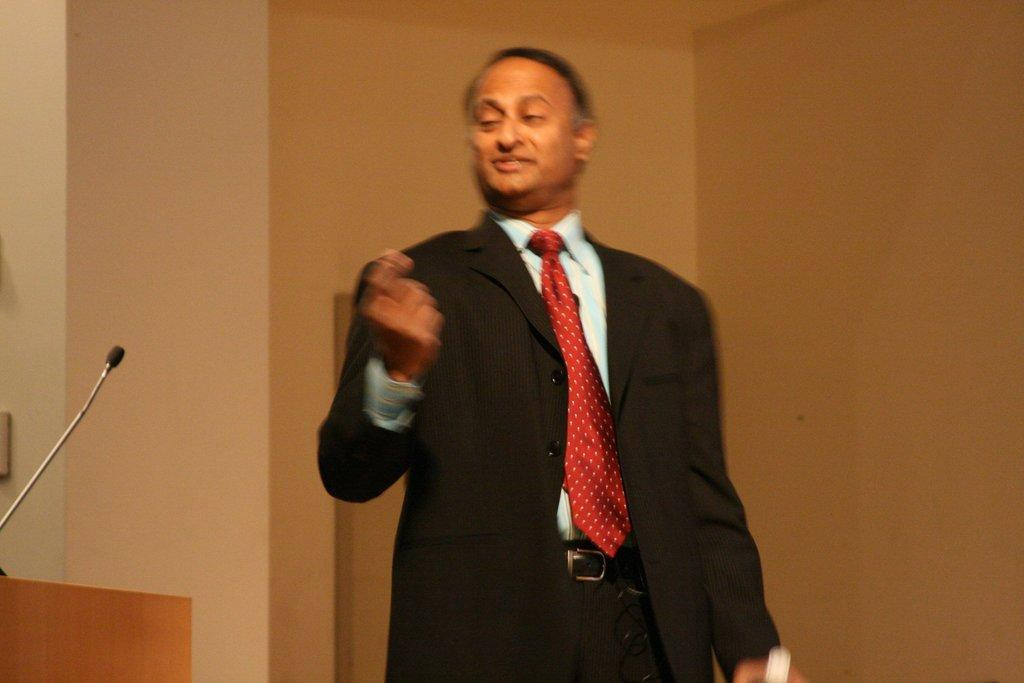What is the main subject of the image? There is a man standing in the image. What can be seen on the left side of the image? There is a mic and a podium on the left side of the image. What is visible in the background of the image? There is a wall in the background of the image. How many passengers are visible in the image? There are no passengers present in the image. What type of building can be seen in the background of the image? There is no building visible in the background of the image; only a wall is present. 